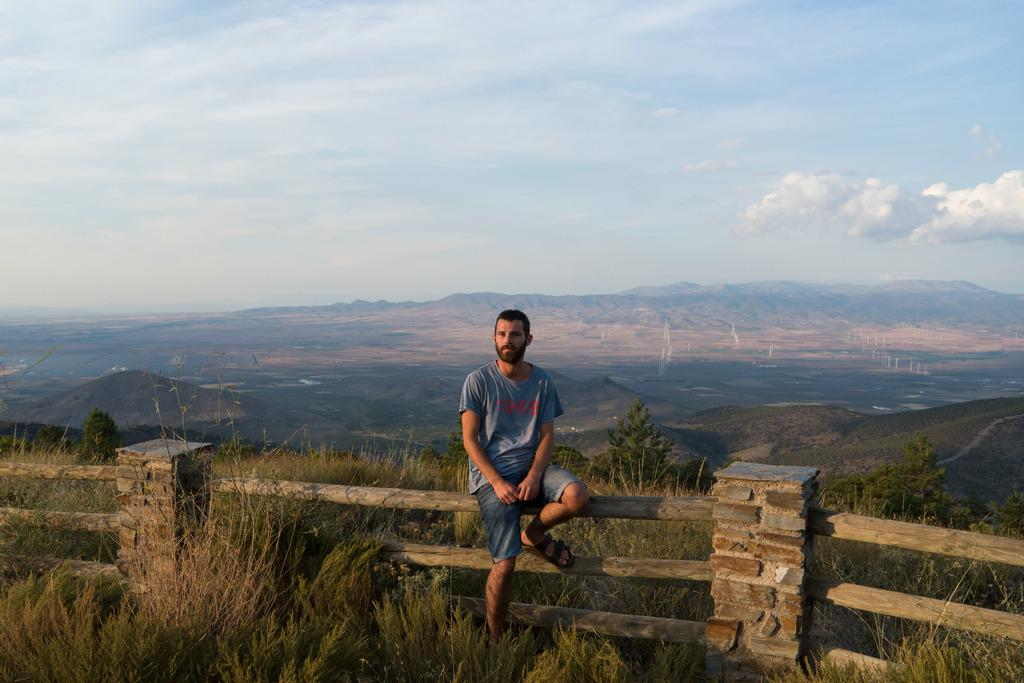What is the person in the image doing? The person is sitting on the fence in the image. What type of vegetation can be seen in the image? There are plants, grass, and trees in the image. What type of landscape is visible in the image? There are hills in the image. What is visible in the background of the image? The sky is visible in the background of the image. What type of juice is being served in the image? There is no juice present in the image. What is the person's hope for the future, as depicted in the image? The image does not provide any information about the person's hopes or future plans. 